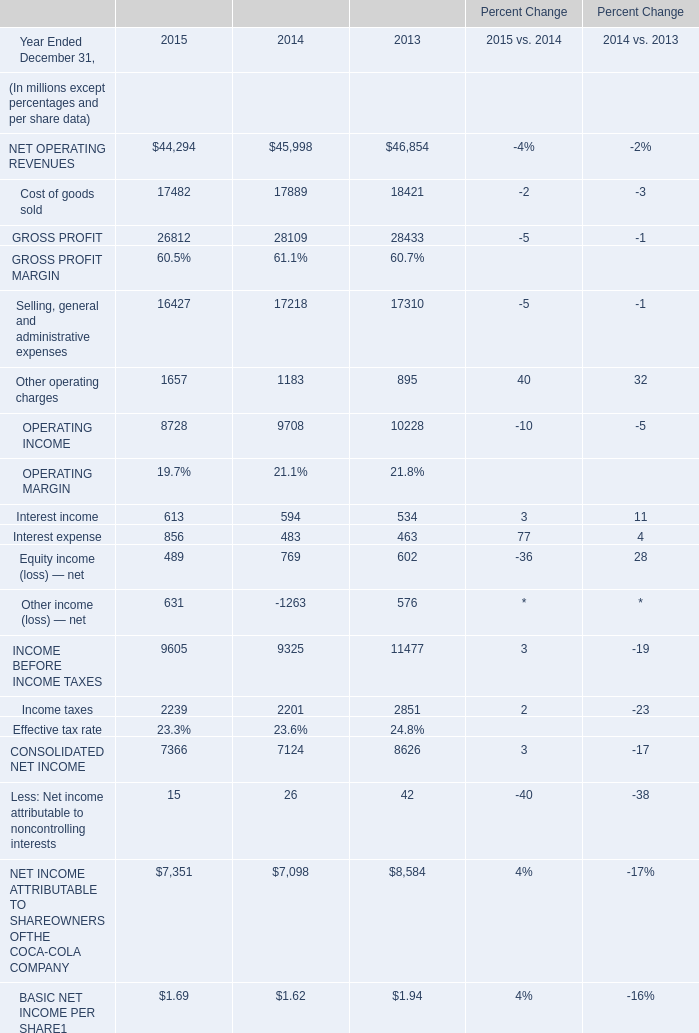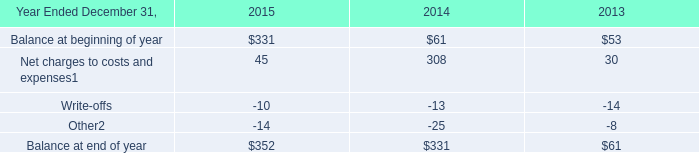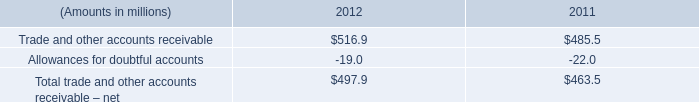What was the total amount of the Interest income in the years where OPERATING INCOME greater than 9000? (in million) 
Computations: (594 + 534)
Answer: 1128.0. 